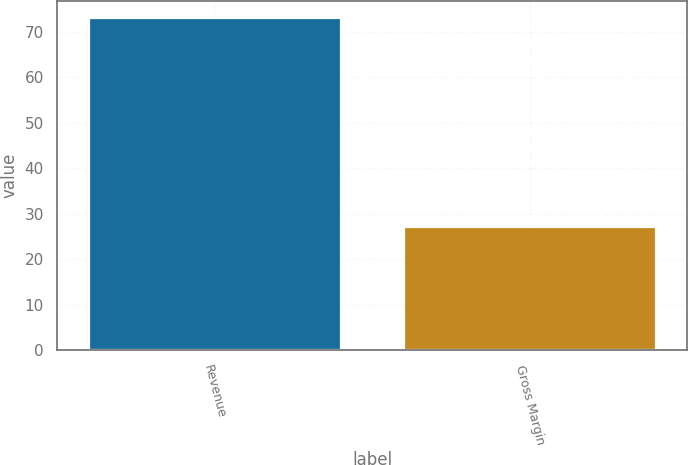<chart> <loc_0><loc_0><loc_500><loc_500><bar_chart><fcel>Revenue<fcel>Gross Margin<nl><fcel>73<fcel>27<nl></chart> 